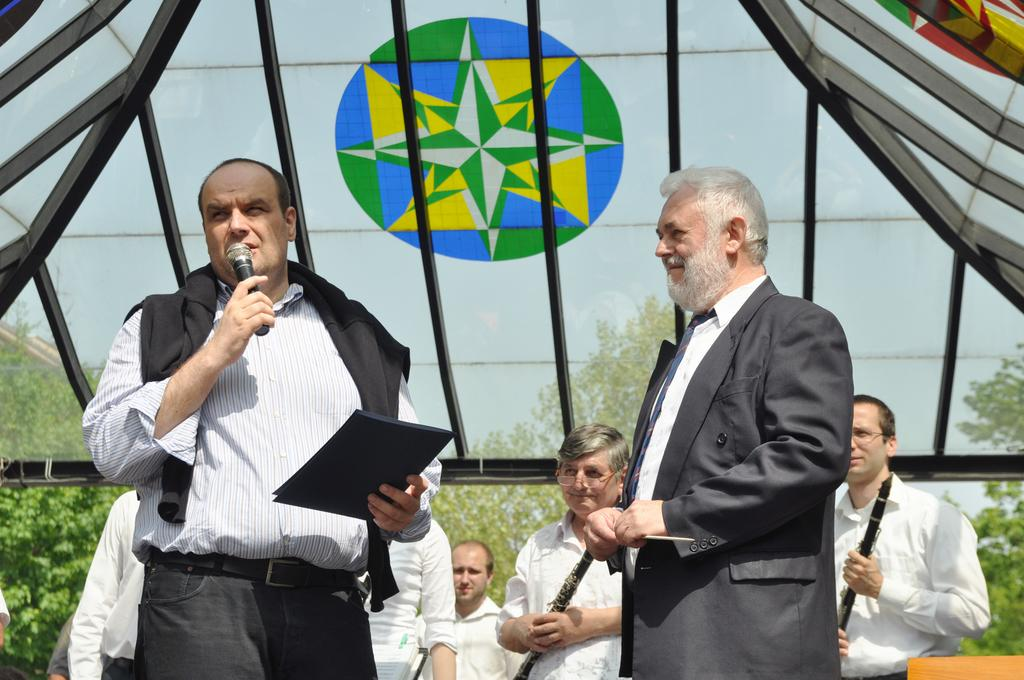Who or what can be seen in the image? There are people in the image. What can be seen in the distance behind the people? There are trees in the background of the image. What else is visible in the background of the image? The sky is visible in the background of the image. What boundary is visible in the image? There is no boundary visible in the image. Can you tell me how many visitors are present in the image? The term "visitor" is not mentioned in the provided facts, so it cannot be determined from the image. 